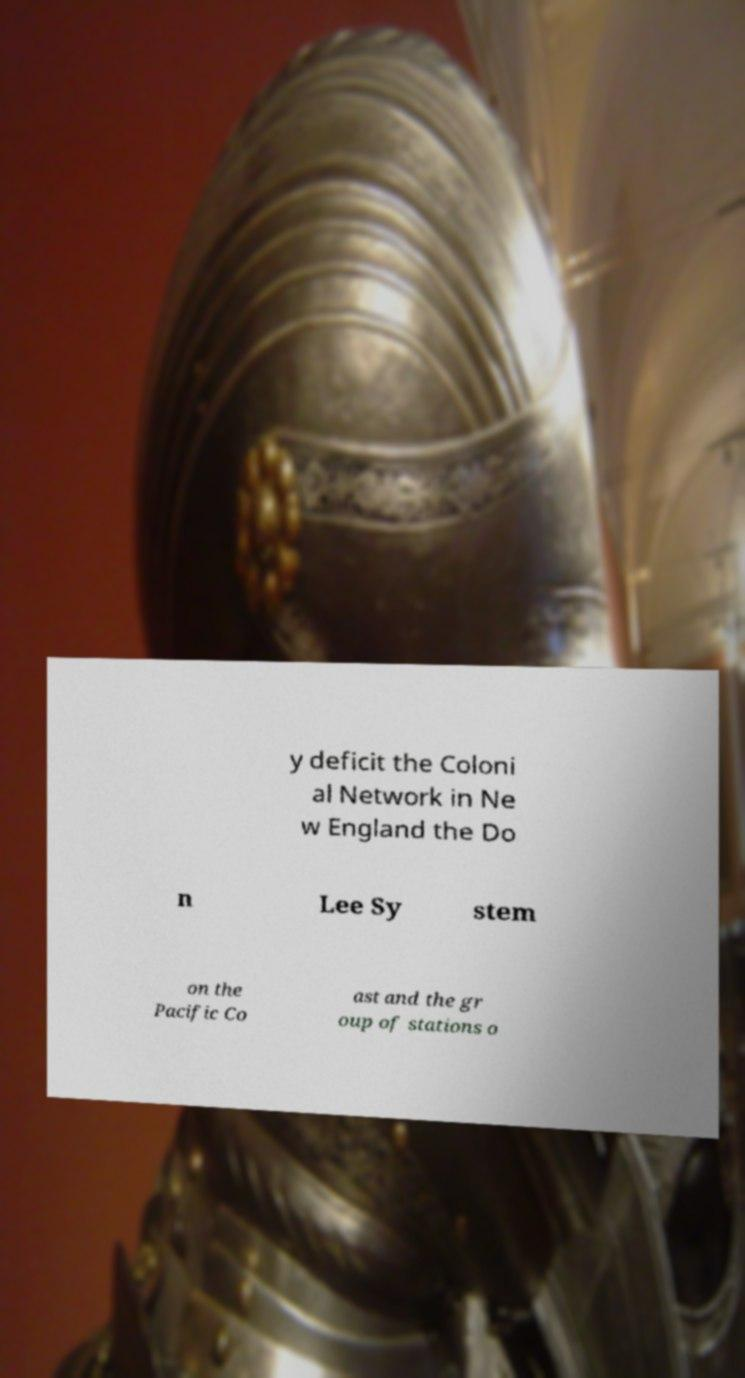For documentation purposes, I need the text within this image transcribed. Could you provide that? y deficit the Coloni al Network in Ne w England the Do n Lee Sy stem on the Pacific Co ast and the gr oup of stations o 